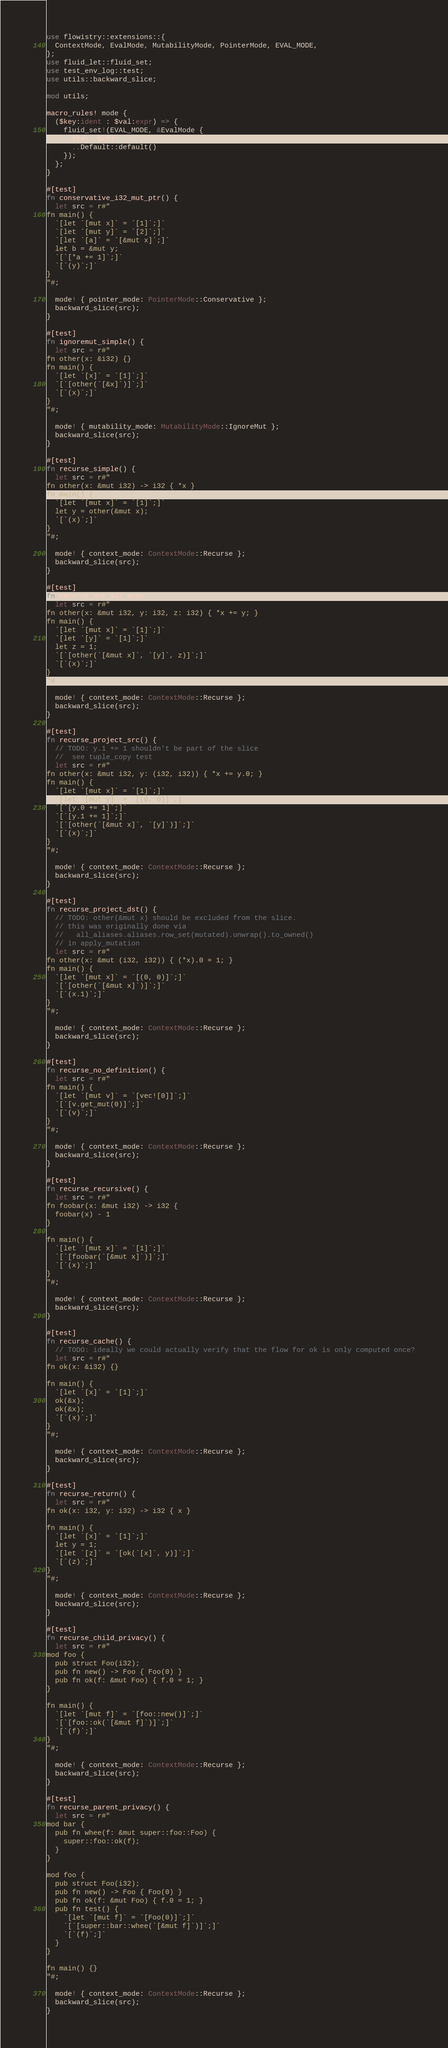<code> <loc_0><loc_0><loc_500><loc_500><_Rust_>use flowistry::extensions::{
  ContextMode, EvalMode, MutabilityMode, PointerMode, EVAL_MODE,
};
use fluid_let::fluid_set;
use test_env_log::test;
use utils::backward_slice;

mod utils;

macro_rules! mode {
  ($key:ident : $val:expr) => {
    fluid_set!(EVAL_MODE, &EvalMode {
      $key: $val,
      ..Default::default()
    });
  };
}

#[test]
fn conservative_i32_mut_ptr() {
  let src = r#"
fn main() {
  `[let `[mut x]` = `[1]`;]`
  `[let `[mut y]` = `[2]`;]`
  `[let `[a]` = `[&mut x]`;]`
  let b = &mut y;
  `[`[*a += 1]`;]`
  `[`(y)`;]`
}
"#;

  mode! { pointer_mode: PointerMode::Conservative };
  backward_slice(src);
}

#[test]
fn ignoremut_simple() {
  let src = r#"
fn other(x: &i32) {}
fn main() {
  `[let `[x]` = `[1]`;]`
  `[`[other(`[&x]`)]`;]`
  `[`(x)`;]`
}
"#;

  mode! { mutability_mode: MutabilityMode::IgnoreMut };
  backward_slice(src);
}

#[test]
fn recurse_simple() {
  let src = r#"
fn other(x: &mut i32) -> i32 { *x }
fn main() {
  `[let `[mut x]` = `[1]`;]`
  let y = other(&mut x);
  `[`(x)`;]`
}
"#;

  mode! { context_mode: ContextMode::Recurse };
  backward_slice(src);
}

#[test]
fn recurse_not_all_args() {
  let src = r#"
fn other(x: &mut i32, y: i32, z: i32) { *x += y; }
fn main() {
  `[let `[mut x]` = `[1]`;]`
  `[let `[y]` = `[1]`;]`
  let z = 1;
  `[`[other(`[&mut x]`, `[y]`, z)]`;]`
  `[`(x)`;]`
}
"#;

  mode! { context_mode: ContextMode::Recurse };
  backward_slice(src);
}

#[test]
fn recurse_project_src() {
  // TODO: y.1 += 1 shouldn't be part of the slice
  //  see tuple_copy test
  let src = r#"
fn other(x: &mut i32, y: (i32, i32)) { *x += y.0; }
fn main() {
  `[let `[mut x]` = `[1]`;]`
  `[let `[mut y]` = `[(0, 0)]`;]`
  `[`[y.0 += 1]`;]`
  `[`[y.1 += 1]`;]`
  `[`[other(`[&mut x]`, `[y]`)]`;]`
  `[`(x)`;]`
}
"#;

  mode! { context_mode: ContextMode::Recurse };
  backward_slice(src);
}

#[test]
fn recurse_project_dst() {
  // TODO: other(&mut x) should be excluded from the slice.
  // this was originally done via
  //   all_aliases.aliases.row_set(mutated).unwrap().to_owned()
  // in apply_mutation
  let src = r#"
fn other(x: &mut (i32, i32)) { (*x).0 = 1; }
fn main() {
  `[let `[mut x]` = `[(0, 0)]`;]`
  `[`[other(`[&mut x]`)]`;]`
  `[`(x.1)`;]`
}
"#;

  mode! { context_mode: ContextMode::Recurse };
  backward_slice(src);
}

#[test]
fn recurse_no_definition() {
  let src = r#"
fn main() {
  `[let `[mut v]` = `[vec![0]]`;]`
  `[`[v.get_mut(0)]`;]`
  `[`(v)`;]`
}
"#;

  mode! { context_mode: ContextMode::Recurse };
  backward_slice(src);
}

#[test]
fn recurse_recursive() {
  let src = r#"
fn foobar(x: &mut i32) -> i32 {
  foobar(x) - 1
}

fn main() {
  `[let `[mut x]` = `[1]`;]`
  `[`[foobar(`[&mut x]`)]`;]`
  `[`(x)`;]`
}
"#;

  mode! { context_mode: ContextMode::Recurse };
  backward_slice(src);
}

#[test]
fn recurse_cache() {
  // TODO: ideally we could actually verify that the flow for ok is only computed once?
  let src = r#"
fn ok(x: &i32) {}

fn main() {
  `[let `[x]` = `[1]`;]`
  ok(&x);
  ok(&x);
  `[`(x)`;]`
}
"#;

  mode! { context_mode: ContextMode::Recurse };
  backward_slice(src);
}

#[test]
fn recurse_return() {
  let src = r#"
fn ok(x: i32, y: i32) -> i32 { x }

fn main() {
  `[let `[x]` = `[1]`;]`
  let y = 1;
  `[let `[z]` = `[ok(`[x]`, y)]`;]`
  `[`(z)`;]`  
}
"#;

  mode! { context_mode: ContextMode::Recurse };
  backward_slice(src);
}

#[test]
fn recurse_child_privacy() {
  let src = r#"
mod foo {
  pub struct Foo(i32);
  pub fn new() -> Foo { Foo(0) }
  pub fn ok(f: &mut Foo) { f.0 = 1; }
}  

fn main() {
  `[let `[mut f]` = `[foo::new()]`;]`
  `[`[foo::ok(`[&mut f]`)]`;]`
  `[`(f)`;]`
}
"#;

  mode! { context_mode: ContextMode::Recurse };
  backward_slice(src);
}

#[test]
fn recurse_parent_privacy() {
  let src = r#"
mod bar {
  pub fn whee(f: &mut super::foo::Foo) {
    super::foo::ok(f);
  }
} 

mod foo {
  pub struct Foo(i32);
  pub fn new() -> Foo { Foo(0) }
  pub fn ok(f: &mut Foo) { f.0 = 1; }
  pub fn test() {
    `[let `[mut f]` = `[Foo(0)]`;]`
    `[`[super::bar::whee(`[&mut f]`)]`;]`
    `[`(f)`;]`
  }
}  

fn main() {}
"#;

  mode! { context_mode: ContextMode::Recurse };
  backward_slice(src);
}
</code> 